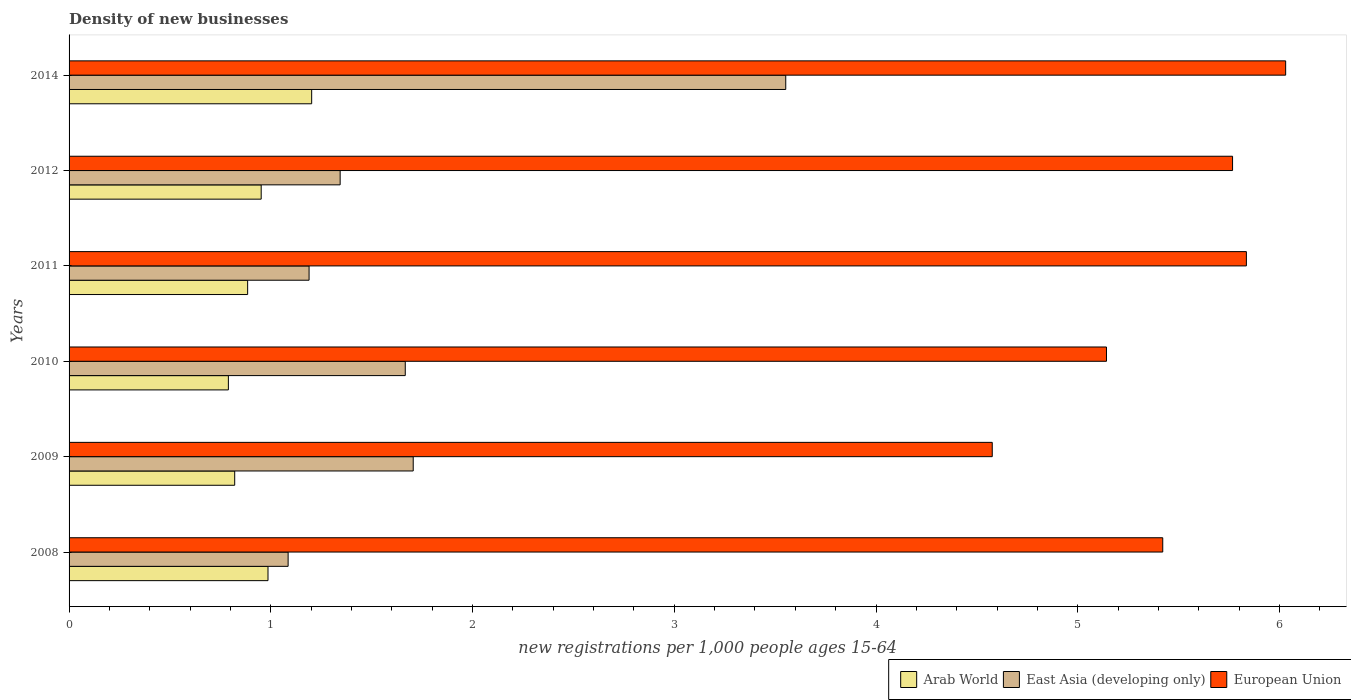How many different coloured bars are there?
Keep it short and to the point. 3. How many groups of bars are there?
Your answer should be very brief. 6. Are the number of bars per tick equal to the number of legend labels?
Make the answer very short. Yes. Are the number of bars on each tick of the Y-axis equal?
Your response must be concise. Yes. In how many cases, is the number of bars for a given year not equal to the number of legend labels?
Offer a very short reply. 0. What is the number of new registrations in East Asia (developing only) in 2009?
Your response must be concise. 1.71. Across all years, what is the maximum number of new registrations in Arab World?
Ensure brevity in your answer.  1.2. Across all years, what is the minimum number of new registrations in Arab World?
Keep it short and to the point. 0.79. In which year was the number of new registrations in East Asia (developing only) maximum?
Your answer should be compact. 2014. In which year was the number of new registrations in Arab World minimum?
Your response must be concise. 2010. What is the total number of new registrations in Arab World in the graph?
Your answer should be compact. 5.64. What is the difference between the number of new registrations in East Asia (developing only) in 2010 and that in 2012?
Give a very brief answer. 0.32. What is the difference between the number of new registrations in East Asia (developing only) in 2009 and the number of new registrations in European Union in 2014?
Your answer should be very brief. -4.32. What is the average number of new registrations in East Asia (developing only) per year?
Provide a succinct answer. 1.76. In the year 2010, what is the difference between the number of new registrations in East Asia (developing only) and number of new registrations in European Union?
Your response must be concise. -3.48. What is the ratio of the number of new registrations in East Asia (developing only) in 2011 to that in 2012?
Ensure brevity in your answer.  0.89. Is the number of new registrations in East Asia (developing only) in 2009 less than that in 2014?
Your answer should be compact. Yes. Is the difference between the number of new registrations in East Asia (developing only) in 2008 and 2012 greater than the difference between the number of new registrations in European Union in 2008 and 2012?
Give a very brief answer. Yes. What is the difference between the highest and the second highest number of new registrations in European Union?
Ensure brevity in your answer.  0.19. What is the difference between the highest and the lowest number of new registrations in Arab World?
Make the answer very short. 0.41. In how many years, is the number of new registrations in European Union greater than the average number of new registrations in European Union taken over all years?
Your response must be concise. 3. What does the 2nd bar from the top in 2014 represents?
Provide a succinct answer. East Asia (developing only). Is it the case that in every year, the sum of the number of new registrations in Arab World and number of new registrations in East Asia (developing only) is greater than the number of new registrations in European Union?
Your answer should be compact. No. How many bars are there?
Offer a terse response. 18. Are the values on the major ticks of X-axis written in scientific E-notation?
Keep it short and to the point. No. Does the graph contain grids?
Your answer should be compact. No. Where does the legend appear in the graph?
Keep it short and to the point. Bottom right. How many legend labels are there?
Your answer should be compact. 3. How are the legend labels stacked?
Provide a short and direct response. Horizontal. What is the title of the graph?
Give a very brief answer. Density of new businesses. What is the label or title of the X-axis?
Provide a succinct answer. New registrations per 1,0 people ages 15-64. What is the label or title of the Y-axis?
Your answer should be compact. Years. What is the new registrations per 1,000 people ages 15-64 of Arab World in 2008?
Make the answer very short. 0.99. What is the new registrations per 1,000 people ages 15-64 in East Asia (developing only) in 2008?
Your answer should be compact. 1.09. What is the new registrations per 1,000 people ages 15-64 of European Union in 2008?
Provide a short and direct response. 5.42. What is the new registrations per 1,000 people ages 15-64 of Arab World in 2009?
Your answer should be very brief. 0.82. What is the new registrations per 1,000 people ages 15-64 in East Asia (developing only) in 2009?
Give a very brief answer. 1.71. What is the new registrations per 1,000 people ages 15-64 of European Union in 2009?
Provide a short and direct response. 4.58. What is the new registrations per 1,000 people ages 15-64 of Arab World in 2010?
Your answer should be very brief. 0.79. What is the new registrations per 1,000 people ages 15-64 of East Asia (developing only) in 2010?
Ensure brevity in your answer.  1.67. What is the new registrations per 1,000 people ages 15-64 in European Union in 2010?
Your answer should be compact. 5.14. What is the new registrations per 1,000 people ages 15-64 in Arab World in 2011?
Your answer should be very brief. 0.89. What is the new registrations per 1,000 people ages 15-64 in East Asia (developing only) in 2011?
Offer a very short reply. 1.19. What is the new registrations per 1,000 people ages 15-64 of European Union in 2011?
Provide a succinct answer. 5.84. What is the new registrations per 1,000 people ages 15-64 of Arab World in 2012?
Provide a short and direct response. 0.95. What is the new registrations per 1,000 people ages 15-64 in East Asia (developing only) in 2012?
Provide a succinct answer. 1.34. What is the new registrations per 1,000 people ages 15-64 of European Union in 2012?
Give a very brief answer. 5.77. What is the new registrations per 1,000 people ages 15-64 in Arab World in 2014?
Make the answer very short. 1.2. What is the new registrations per 1,000 people ages 15-64 in East Asia (developing only) in 2014?
Provide a short and direct response. 3.55. What is the new registrations per 1,000 people ages 15-64 of European Union in 2014?
Make the answer very short. 6.03. Across all years, what is the maximum new registrations per 1,000 people ages 15-64 of Arab World?
Keep it short and to the point. 1.2. Across all years, what is the maximum new registrations per 1,000 people ages 15-64 of East Asia (developing only)?
Keep it short and to the point. 3.55. Across all years, what is the maximum new registrations per 1,000 people ages 15-64 in European Union?
Your response must be concise. 6.03. Across all years, what is the minimum new registrations per 1,000 people ages 15-64 in Arab World?
Keep it short and to the point. 0.79. Across all years, what is the minimum new registrations per 1,000 people ages 15-64 of East Asia (developing only)?
Offer a terse response. 1.09. Across all years, what is the minimum new registrations per 1,000 people ages 15-64 of European Union?
Ensure brevity in your answer.  4.58. What is the total new registrations per 1,000 people ages 15-64 of Arab World in the graph?
Provide a succinct answer. 5.64. What is the total new registrations per 1,000 people ages 15-64 in East Asia (developing only) in the graph?
Your response must be concise. 10.54. What is the total new registrations per 1,000 people ages 15-64 in European Union in the graph?
Give a very brief answer. 32.77. What is the difference between the new registrations per 1,000 people ages 15-64 in Arab World in 2008 and that in 2009?
Your response must be concise. 0.17. What is the difference between the new registrations per 1,000 people ages 15-64 of East Asia (developing only) in 2008 and that in 2009?
Offer a terse response. -0.62. What is the difference between the new registrations per 1,000 people ages 15-64 of European Union in 2008 and that in 2009?
Provide a succinct answer. 0.85. What is the difference between the new registrations per 1,000 people ages 15-64 of Arab World in 2008 and that in 2010?
Your response must be concise. 0.2. What is the difference between the new registrations per 1,000 people ages 15-64 in East Asia (developing only) in 2008 and that in 2010?
Keep it short and to the point. -0.58. What is the difference between the new registrations per 1,000 people ages 15-64 of European Union in 2008 and that in 2010?
Offer a terse response. 0.28. What is the difference between the new registrations per 1,000 people ages 15-64 in Arab World in 2008 and that in 2011?
Your answer should be compact. 0.1. What is the difference between the new registrations per 1,000 people ages 15-64 of East Asia (developing only) in 2008 and that in 2011?
Keep it short and to the point. -0.1. What is the difference between the new registrations per 1,000 people ages 15-64 in European Union in 2008 and that in 2011?
Your answer should be very brief. -0.41. What is the difference between the new registrations per 1,000 people ages 15-64 of Arab World in 2008 and that in 2012?
Make the answer very short. 0.03. What is the difference between the new registrations per 1,000 people ages 15-64 in East Asia (developing only) in 2008 and that in 2012?
Make the answer very short. -0.26. What is the difference between the new registrations per 1,000 people ages 15-64 of European Union in 2008 and that in 2012?
Make the answer very short. -0.35. What is the difference between the new registrations per 1,000 people ages 15-64 in Arab World in 2008 and that in 2014?
Make the answer very short. -0.22. What is the difference between the new registrations per 1,000 people ages 15-64 in East Asia (developing only) in 2008 and that in 2014?
Offer a very short reply. -2.47. What is the difference between the new registrations per 1,000 people ages 15-64 in European Union in 2008 and that in 2014?
Offer a terse response. -0.61. What is the difference between the new registrations per 1,000 people ages 15-64 in Arab World in 2009 and that in 2010?
Offer a terse response. 0.03. What is the difference between the new registrations per 1,000 people ages 15-64 in East Asia (developing only) in 2009 and that in 2010?
Provide a succinct answer. 0.04. What is the difference between the new registrations per 1,000 people ages 15-64 of European Union in 2009 and that in 2010?
Offer a terse response. -0.57. What is the difference between the new registrations per 1,000 people ages 15-64 in Arab World in 2009 and that in 2011?
Make the answer very short. -0.06. What is the difference between the new registrations per 1,000 people ages 15-64 of East Asia (developing only) in 2009 and that in 2011?
Provide a succinct answer. 0.52. What is the difference between the new registrations per 1,000 people ages 15-64 of European Union in 2009 and that in 2011?
Your answer should be compact. -1.26. What is the difference between the new registrations per 1,000 people ages 15-64 in Arab World in 2009 and that in 2012?
Ensure brevity in your answer.  -0.13. What is the difference between the new registrations per 1,000 people ages 15-64 in East Asia (developing only) in 2009 and that in 2012?
Give a very brief answer. 0.36. What is the difference between the new registrations per 1,000 people ages 15-64 in European Union in 2009 and that in 2012?
Provide a succinct answer. -1.19. What is the difference between the new registrations per 1,000 people ages 15-64 in Arab World in 2009 and that in 2014?
Keep it short and to the point. -0.38. What is the difference between the new registrations per 1,000 people ages 15-64 in East Asia (developing only) in 2009 and that in 2014?
Provide a succinct answer. -1.85. What is the difference between the new registrations per 1,000 people ages 15-64 in European Union in 2009 and that in 2014?
Offer a very short reply. -1.45. What is the difference between the new registrations per 1,000 people ages 15-64 in Arab World in 2010 and that in 2011?
Make the answer very short. -0.1. What is the difference between the new registrations per 1,000 people ages 15-64 in East Asia (developing only) in 2010 and that in 2011?
Your answer should be very brief. 0.48. What is the difference between the new registrations per 1,000 people ages 15-64 of European Union in 2010 and that in 2011?
Give a very brief answer. -0.69. What is the difference between the new registrations per 1,000 people ages 15-64 in Arab World in 2010 and that in 2012?
Offer a terse response. -0.16. What is the difference between the new registrations per 1,000 people ages 15-64 of East Asia (developing only) in 2010 and that in 2012?
Ensure brevity in your answer.  0.32. What is the difference between the new registrations per 1,000 people ages 15-64 of European Union in 2010 and that in 2012?
Keep it short and to the point. -0.62. What is the difference between the new registrations per 1,000 people ages 15-64 of Arab World in 2010 and that in 2014?
Provide a short and direct response. -0.41. What is the difference between the new registrations per 1,000 people ages 15-64 of East Asia (developing only) in 2010 and that in 2014?
Keep it short and to the point. -1.89. What is the difference between the new registrations per 1,000 people ages 15-64 of European Union in 2010 and that in 2014?
Offer a very short reply. -0.89. What is the difference between the new registrations per 1,000 people ages 15-64 of Arab World in 2011 and that in 2012?
Provide a short and direct response. -0.07. What is the difference between the new registrations per 1,000 people ages 15-64 in East Asia (developing only) in 2011 and that in 2012?
Provide a short and direct response. -0.15. What is the difference between the new registrations per 1,000 people ages 15-64 of European Union in 2011 and that in 2012?
Make the answer very short. 0.07. What is the difference between the new registrations per 1,000 people ages 15-64 in Arab World in 2011 and that in 2014?
Make the answer very short. -0.32. What is the difference between the new registrations per 1,000 people ages 15-64 of East Asia (developing only) in 2011 and that in 2014?
Offer a very short reply. -2.36. What is the difference between the new registrations per 1,000 people ages 15-64 of European Union in 2011 and that in 2014?
Your answer should be very brief. -0.19. What is the difference between the new registrations per 1,000 people ages 15-64 of Arab World in 2012 and that in 2014?
Your answer should be compact. -0.25. What is the difference between the new registrations per 1,000 people ages 15-64 in East Asia (developing only) in 2012 and that in 2014?
Give a very brief answer. -2.21. What is the difference between the new registrations per 1,000 people ages 15-64 in European Union in 2012 and that in 2014?
Your answer should be very brief. -0.26. What is the difference between the new registrations per 1,000 people ages 15-64 of Arab World in 2008 and the new registrations per 1,000 people ages 15-64 of East Asia (developing only) in 2009?
Give a very brief answer. -0.72. What is the difference between the new registrations per 1,000 people ages 15-64 of Arab World in 2008 and the new registrations per 1,000 people ages 15-64 of European Union in 2009?
Provide a short and direct response. -3.59. What is the difference between the new registrations per 1,000 people ages 15-64 in East Asia (developing only) in 2008 and the new registrations per 1,000 people ages 15-64 in European Union in 2009?
Your answer should be compact. -3.49. What is the difference between the new registrations per 1,000 people ages 15-64 of Arab World in 2008 and the new registrations per 1,000 people ages 15-64 of East Asia (developing only) in 2010?
Make the answer very short. -0.68. What is the difference between the new registrations per 1,000 people ages 15-64 of Arab World in 2008 and the new registrations per 1,000 people ages 15-64 of European Union in 2010?
Provide a short and direct response. -4.16. What is the difference between the new registrations per 1,000 people ages 15-64 in East Asia (developing only) in 2008 and the new registrations per 1,000 people ages 15-64 in European Union in 2010?
Ensure brevity in your answer.  -4.06. What is the difference between the new registrations per 1,000 people ages 15-64 in Arab World in 2008 and the new registrations per 1,000 people ages 15-64 in East Asia (developing only) in 2011?
Your answer should be very brief. -0.2. What is the difference between the new registrations per 1,000 people ages 15-64 of Arab World in 2008 and the new registrations per 1,000 people ages 15-64 of European Union in 2011?
Provide a succinct answer. -4.85. What is the difference between the new registrations per 1,000 people ages 15-64 of East Asia (developing only) in 2008 and the new registrations per 1,000 people ages 15-64 of European Union in 2011?
Keep it short and to the point. -4.75. What is the difference between the new registrations per 1,000 people ages 15-64 of Arab World in 2008 and the new registrations per 1,000 people ages 15-64 of East Asia (developing only) in 2012?
Provide a succinct answer. -0.36. What is the difference between the new registrations per 1,000 people ages 15-64 in Arab World in 2008 and the new registrations per 1,000 people ages 15-64 in European Union in 2012?
Give a very brief answer. -4.78. What is the difference between the new registrations per 1,000 people ages 15-64 of East Asia (developing only) in 2008 and the new registrations per 1,000 people ages 15-64 of European Union in 2012?
Offer a very short reply. -4.68. What is the difference between the new registrations per 1,000 people ages 15-64 of Arab World in 2008 and the new registrations per 1,000 people ages 15-64 of East Asia (developing only) in 2014?
Provide a short and direct response. -2.57. What is the difference between the new registrations per 1,000 people ages 15-64 of Arab World in 2008 and the new registrations per 1,000 people ages 15-64 of European Union in 2014?
Your response must be concise. -5.04. What is the difference between the new registrations per 1,000 people ages 15-64 in East Asia (developing only) in 2008 and the new registrations per 1,000 people ages 15-64 in European Union in 2014?
Ensure brevity in your answer.  -4.94. What is the difference between the new registrations per 1,000 people ages 15-64 in Arab World in 2009 and the new registrations per 1,000 people ages 15-64 in East Asia (developing only) in 2010?
Make the answer very short. -0.85. What is the difference between the new registrations per 1,000 people ages 15-64 in Arab World in 2009 and the new registrations per 1,000 people ages 15-64 in European Union in 2010?
Offer a very short reply. -4.32. What is the difference between the new registrations per 1,000 people ages 15-64 of East Asia (developing only) in 2009 and the new registrations per 1,000 people ages 15-64 of European Union in 2010?
Your answer should be compact. -3.44. What is the difference between the new registrations per 1,000 people ages 15-64 in Arab World in 2009 and the new registrations per 1,000 people ages 15-64 in East Asia (developing only) in 2011?
Ensure brevity in your answer.  -0.37. What is the difference between the new registrations per 1,000 people ages 15-64 of Arab World in 2009 and the new registrations per 1,000 people ages 15-64 of European Union in 2011?
Your answer should be very brief. -5.01. What is the difference between the new registrations per 1,000 people ages 15-64 in East Asia (developing only) in 2009 and the new registrations per 1,000 people ages 15-64 in European Union in 2011?
Offer a very short reply. -4.13. What is the difference between the new registrations per 1,000 people ages 15-64 of Arab World in 2009 and the new registrations per 1,000 people ages 15-64 of East Asia (developing only) in 2012?
Offer a very short reply. -0.52. What is the difference between the new registrations per 1,000 people ages 15-64 of Arab World in 2009 and the new registrations per 1,000 people ages 15-64 of European Union in 2012?
Keep it short and to the point. -4.95. What is the difference between the new registrations per 1,000 people ages 15-64 of East Asia (developing only) in 2009 and the new registrations per 1,000 people ages 15-64 of European Union in 2012?
Give a very brief answer. -4.06. What is the difference between the new registrations per 1,000 people ages 15-64 in Arab World in 2009 and the new registrations per 1,000 people ages 15-64 in East Asia (developing only) in 2014?
Your answer should be very brief. -2.73. What is the difference between the new registrations per 1,000 people ages 15-64 of Arab World in 2009 and the new registrations per 1,000 people ages 15-64 of European Union in 2014?
Your answer should be compact. -5.21. What is the difference between the new registrations per 1,000 people ages 15-64 in East Asia (developing only) in 2009 and the new registrations per 1,000 people ages 15-64 in European Union in 2014?
Your answer should be compact. -4.32. What is the difference between the new registrations per 1,000 people ages 15-64 of Arab World in 2010 and the new registrations per 1,000 people ages 15-64 of European Union in 2011?
Provide a succinct answer. -5.05. What is the difference between the new registrations per 1,000 people ages 15-64 of East Asia (developing only) in 2010 and the new registrations per 1,000 people ages 15-64 of European Union in 2011?
Offer a terse response. -4.17. What is the difference between the new registrations per 1,000 people ages 15-64 in Arab World in 2010 and the new registrations per 1,000 people ages 15-64 in East Asia (developing only) in 2012?
Your answer should be compact. -0.55. What is the difference between the new registrations per 1,000 people ages 15-64 of Arab World in 2010 and the new registrations per 1,000 people ages 15-64 of European Union in 2012?
Ensure brevity in your answer.  -4.98. What is the difference between the new registrations per 1,000 people ages 15-64 of East Asia (developing only) in 2010 and the new registrations per 1,000 people ages 15-64 of European Union in 2012?
Make the answer very short. -4.1. What is the difference between the new registrations per 1,000 people ages 15-64 of Arab World in 2010 and the new registrations per 1,000 people ages 15-64 of East Asia (developing only) in 2014?
Offer a terse response. -2.76. What is the difference between the new registrations per 1,000 people ages 15-64 of Arab World in 2010 and the new registrations per 1,000 people ages 15-64 of European Union in 2014?
Give a very brief answer. -5.24. What is the difference between the new registrations per 1,000 people ages 15-64 of East Asia (developing only) in 2010 and the new registrations per 1,000 people ages 15-64 of European Union in 2014?
Your answer should be compact. -4.36. What is the difference between the new registrations per 1,000 people ages 15-64 in Arab World in 2011 and the new registrations per 1,000 people ages 15-64 in East Asia (developing only) in 2012?
Provide a succinct answer. -0.46. What is the difference between the new registrations per 1,000 people ages 15-64 of Arab World in 2011 and the new registrations per 1,000 people ages 15-64 of European Union in 2012?
Your answer should be very brief. -4.88. What is the difference between the new registrations per 1,000 people ages 15-64 of East Asia (developing only) in 2011 and the new registrations per 1,000 people ages 15-64 of European Union in 2012?
Your response must be concise. -4.58. What is the difference between the new registrations per 1,000 people ages 15-64 of Arab World in 2011 and the new registrations per 1,000 people ages 15-64 of East Asia (developing only) in 2014?
Your answer should be very brief. -2.67. What is the difference between the new registrations per 1,000 people ages 15-64 in Arab World in 2011 and the new registrations per 1,000 people ages 15-64 in European Union in 2014?
Your response must be concise. -5.15. What is the difference between the new registrations per 1,000 people ages 15-64 of East Asia (developing only) in 2011 and the new registrations per 1,000 people ages 15-64 of European Union in 2014?
Offer a terse response. -4.84. What is the difference between the new registrations per 1,000 people ages 15-64 in Arab World in 2012 and the new registrations per 1,000 people ages 15-64 in East Asia (developing only) in 2014?
Provide a short and direct response. -2.6. What is the difference between the new registrations per 1,000 people ages 15-64 in Arab World in 2012 and the new registrations per 1,000 people ages 15-64 in European Union in 2014?
Your response must be concise. -5.08. What is the difference between the new registrations per 1,000 people ages 15-64 in East Asia (developing only) in 2012 and the new registrations per 1,000 people ages 15-64 in European Union in 2014?
Make the answer very short. -4.69. What is the average new registrations per 1,000 people ages 15-64 of Arab World per year?
Offer a very short reply. 0.94. What is the average new registrations per 1,000 people ages 15-64 of East Asia (developing only) per year?
Give a very brief answer. 1.76. What is the average new registrations per 1,000 people ages 15-64 in European Union per year?
Your answer should be very brief. 5.46. In the year 2008, what is the difference between the new registrations per 1,000 people ages 15-64 in Arab World and new registrations per 1,000 people ages 15-64 in East Asia (developing only)?
Offer a very short reply. -0.1. In the year 2008, what is the difference between the new registrations per 1,000 people ages 15-64 in Arab World and new registrations per 1,000 people ages 15-64 in European Union?
Provide a succinct answer. -4.44. In the year 2008, what is the difference between the new registrations per 1,000 people ages 15-64 of East Asia (developing only) and new registrations per 1,000 people ages 15-64 of European Union?
Provide a short and direct response. -4.34. In the year 2009, what is the difference between the new registrations per 1,000 people ages 15-64 in Arab World and new registrations per 1,000 people ages 15-64 in East Asia (developing only)?
Offer a very short reply. -0.88. In the year 2009, what is the difference between the new registrations per 1,000 people ages 15-64 of Arab World and new registrations per 1,000 people ages 15-64 of European Union?
Your response must be concise. -3.75. In the year 2009, what is the difference between the new registrations per 1,000 people ages 15-64 of East Asia (developing only) and new registrations per 1,000 people ages 15-64 of European Union?
Provide a short and direct response. -2.87. In the year 2010, what is the difference between the new registrations per 1,000 people ages 15-64 in Arab World and new registrations per 1,000 people ages 15-64 in East Asia (developing only)?
Offer a terse response. -0.88. In the year 2010, what is the difference between the new registrations per 1,000 people ages 15-64 of Arab World and new registrations per 1,000 people ages 15-64 of European Union?
Offer a very short reply. -4.35. In the year 2010, what is the difference between the new registrations per 1,000 people ages 15-64 of East Asia (developing only) and new registrations per 1,000 people ages 15-64 of European Union?
Provide a succinct answer. -3.48. In the year 2011, what is the difference between the new registrations per 1,000 people ages 15-64 of Arab World and new registrations per 1,000 people ages 15-64 of East Asia (developing only)?
Provide a succinct answer. -0.3. In the year 2011, what is the difference between the new registrations per 1,000 people ages 15-64 of Arab World and new registrations per 1,000 people ages 15-64 of European Union?
Your answer should be compact. -4.95. In the year 2011, what is the difference between the new registrations per 1,000 people ages 15-64 in East Asia (developing only) and new registrations per 1,000 people ages 15-64 in European Union?
Offer a very short reply. -4.65. In the year 2012, what is the difference between the new registrations per 1,000 people ages 15-64 in Arab World and new registrations per 1,000 people ages 15-64 in East Asia (developing only)?
Give a very brief answer. -0.39. In the year 2012, what is the difference between the new registrations per 1,000 people ages 15-64 of Arab World and new registrations per 1,000 people ages 15-64 of European Union?
Offer a very short reply. -4.81. In the year 2012, what is the difference between the new registrations per 1,000 people ages 15-64 in East Asia (developing only) and new registrations per 1,000 people ages 15-64 in European Union?
Give a very brief answer. -4.42. In the year 2014, what is the difference between the new registrations per 1,000 people ages 15-64 in Arab World and new registrations per 1,000 people ages 15-64 in East Asia (developing only)?
Provide a short and direct response. -2.35. In the year 2014, what is the difference between the new registrations per 1,000 people ages 15-64 in Arab World and new registrations per 1,000 people ages 15-64 in European Union?
Ensure brevity in your answer.  -4.83. In the year 2014, what is the difference between the new registrations per 1,000 people ages 15-64 in East Asia (developing only) and new registrations per 1,000 people ages 15-64 in European Union?
Offer a very short reply. -2.48. What is the ratio of the new registrations per 1,000 people ages 15-64 of Arab World in 2008 to that in 2009?
Keep it short and to the point. 1.2. What is the ratio of the new registrations per 1,000 people ages 15-64 in East Asia (developing only) in 2008 to that in 2009?
Your answer should be very brief. 0.64. What is the ratio of the new registrations per 1,000 people ages 15-64 of European Union in 2008 to that in 2009?
Make the answer very short. 1.18. What is the ratio of the new registrations per 1,000 people ages 15-64 of Arab World in 2008 to that in 2010?
Your answer should be compact. 1.25. What is the ratio of the new registrations per 1,000 people ages 15-64 of East Asia (developing only) in 2008 to that in 2010?
Your answer should be compact. 0.65. What is the ratio of the new registrations per 1,000 people ages 15-64 in European Union in 2008 to that in 2010?
Ensure brevity in your answer.  1.05. What is the ratio of the new registrations per 1,000 people ages 15-64 in Arab World in 2008 to that in 2011?
Provide a succinct answer. 1.11. What is the ratio of the new registrations per 1,000 people ages 15-64 of East Asia (developing only) in 2008 to that in 2011?
Your response must be concise. 0.91. What is the ratio of the new registrations per 1,000 people ages 15-64 of European Union in 2008 to that in 2011?
Your answer should be very brief. 0.93. What is the ratio of the new registrations per 1,000 people ages 15-64 of Arab World in 2008 to that in 2012?
Keep it short and to the point. 1.04. What is the ratio of the new registrations per 1,000 people ages 15-64 in East Asia (developing only) in 2008 to that in 2012?
Make the answer very short. 0.81. What is the ratio of the new registrations per 1,000 people ages 15-64 in European Union in 2008 to that in 2012?
Give a very brief answer. 0.94. What is the ratio of the new registrations per 1,000 people ages 15-64 in Arab World in 2008 to that in 2014?
Your response must be concise. 0.82. What is the ratio of the new registrations per 1,000 people ages 15-64 in East Asia (developing only) in 2008 to that in 2014?
Your answer should be very brief. 0.31. What is the ratio of the new registrations per 1,000 people ages 15-64 in European Union in 2008 to that in 2014?
Keep it short and to the point. 0.9. What is the ratio of the new registrations per 1,000 people ages 15-64 of Arab World in 2009 to that in 2010?
Ensure brevity in your answer.  1.04. What is the ratio of the new registrations per 1,000 people ages 15-64 in East Asia (developing only) in 2009 to that in 2010?
Offer a terse response. 1.02. What is the ratio of the new registrations per 1,000 people ages 15-64 in European Union in 2009 to that in 2010?
Your answer should be compact. 0.89. What is the ratio of the new registrations per 1,000 people ages 15-64 in Arab World in 2009 to that in 2011?
Provide a succinct answer. 0.93. What is the ratio of the new registrations per 1,000 people ages 15-64 in East Asia (developing only) in 2009 to that in 2011?
Make the answer very short. 1.43. What is the ratio of the new registrations per 1,000 people ages 15-64 in European Union in 2009 to that in 2011?
Offer a terse response. 0.78. What is the ratio of the new registrations per 1,000 people ages 15-64 in Arab World in 2009 to that in 2012?
Keep it short and to the point. 0.86. What is the ratio of the new registrations per 1,000 people ages 15-64 in East Asia (developing only) in 2009 to that in 2012?
Provide a succinct answer. 1.27. What is the ratio of the new registrations per 1,000 people ages 15-64 in European Union in 2009 to that in 2012?
Your answer should be very brief. 0.79. What is the ratio of the new registrations per 1,000 people ages 15-64 of Arab World in 2009 to that in 2014?
Provide a succinct answer. 0.68. What is the ratio of the new registrations per 1,000 people ages 15-64 of East Asia (developing only) in 2009 to that in 2014?
Your response must be concise. 0.48. What is the ratio of the new registrations per 1,000 people ages 15-64 of European Union in 2009 to that in 2014?
Provide a succinct answer. 0.76. What is the ratio of the new registrations per 1,000 people ages 15-64 of Arab World in 2010 to that in 2011?
Keep it short and to the point. 0.89. What is the ratio of the new registrations per 1,000 people ages 15-64 of East Asia (developing only) in 2010 to that in 2011?
Offer a terse response. 1.4. What is the ratio of the new registrations per 1,000 people ages 15-64 of European Union in 2010 to that in 2011?
Your response must be concise. 0.88. What is the ratio of the new registrations per 1,000 people ages 15-64 in Arab World in 2010 to that in 2012?
Give a very brief answer. 0.83. What is the ratio of the new registrations per 1,000 people ages 15-64 of East Asia (developing only) in 2010 to that in 2012?
Offer a terse response. 1.24. What is the ratio of the new registrations per 1,000 people ages 15-64 of European Union in 2010 to that in 2012?
Keep it short and to the point. 0.89. What is the ratio of the new registrations per 1,000 people ages 15-64 in Arab World in 2010 to that in 2014?
Provide a short and direct response. 0.66. What is the ratio of the new registrations per 1,000 people ages 15-64 in East Asia (developing only) in 2010 to that in 2014?
Make the answer very short. 0.47. What is the ratio of the new registrations per 1,000 people ages 15-64 in European Union in 2010 to that in 2014?
Your answer should be compact. 0.85. What is the ratio of the new registrations per 1,000 people ages 15-64 in Arab World in 2011 to that in 2012?
Offer a terse response. 0.93. What is the ratio of the new registrations per 1,000 people ages 15-64 of East Asia (developing only) in 2011 to that in 2012?
Provide a succinct answer. 0.89. What is the ratio of the new registrations per 1,000 people ages 15-64 in European Union in 2011 to that in 2012?
Your answer should be compact. 1.01. What is the ratio of the new registrations per 1,000 people ages 15-64 of Arab World in 2011 to that in 2014?
Make the answer very short. 0.74. What is the ratio of the new registrations per 1,000 people ages 15-64 in East Asia (developing only) in 2011 to that in 2014?
Offer a very short reply. 0.33. What is the ratio of the new registrations per 1,000 people ages 15-64 in European Union in 2011 to that in 2014?
Your answer should be compact. 0.97. What is the ratio of the new registrations per 1,000 people ages 15-64 of Arab World in 2012 to that in 2014?
Offer a very short reply. 0.79. What is the ratio of the new registrations per 1,000 people ages 15-64 in East Asia (developing only) in 2012 to that in 2014?
Make the answer very short. 0.38. What is the ratio of the new registrations per 1,000 people ages 15-64 of European Union in 2012 to that in 2014?
Make the answer very short. 0.96. What is the difference between the highest and the second highest new registrations per 1,000 people ages 15-64 in Arab World?
Provide a succinct answer. 0.22. What is the difference between the highest and the second highest new registrations per 1,000 people ages 15-64 of East Asia (developing only)?
Offer a terse response. 1.85. What is the difference between the highest and the second highest new registrations per 1,000 people ages 15-64 of European Union?
Make the answer very short. 0.19. What is the difference between the highest and the lowest new registrations per 1,000 people ages 15-64 of Arab World?
Offer a very short reply. 0.41. What is the difference between the highest and the lowest new registrations per 1,000 people ages 15-64 in East Asia (developing only)?
Your answer should be compact. 2.47. What is the difference between the highest and the lowest new registrations per 1,000 people ages 15-64 in European Union?
Your answer should be compact. 1.45. 